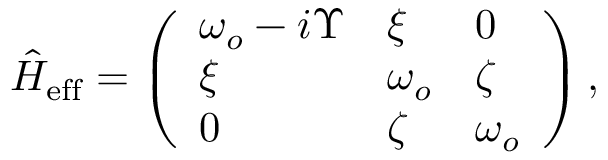<formula> <loc_0><loc_0><loc_500><loc_500>\begin{array} { r } { \hat { H } _ { e f f } = \left ( \begin{array} { l l l } { \omega _ { o } - i \Upsilon } & { \xi } & { 0 } \\ { \xi } & { \omega _ { o } } & { \zeta } \\ { 0 } & { \zeta } & { \omega _ { o } } \end{array} \right ) , } \end{array}</formula> 